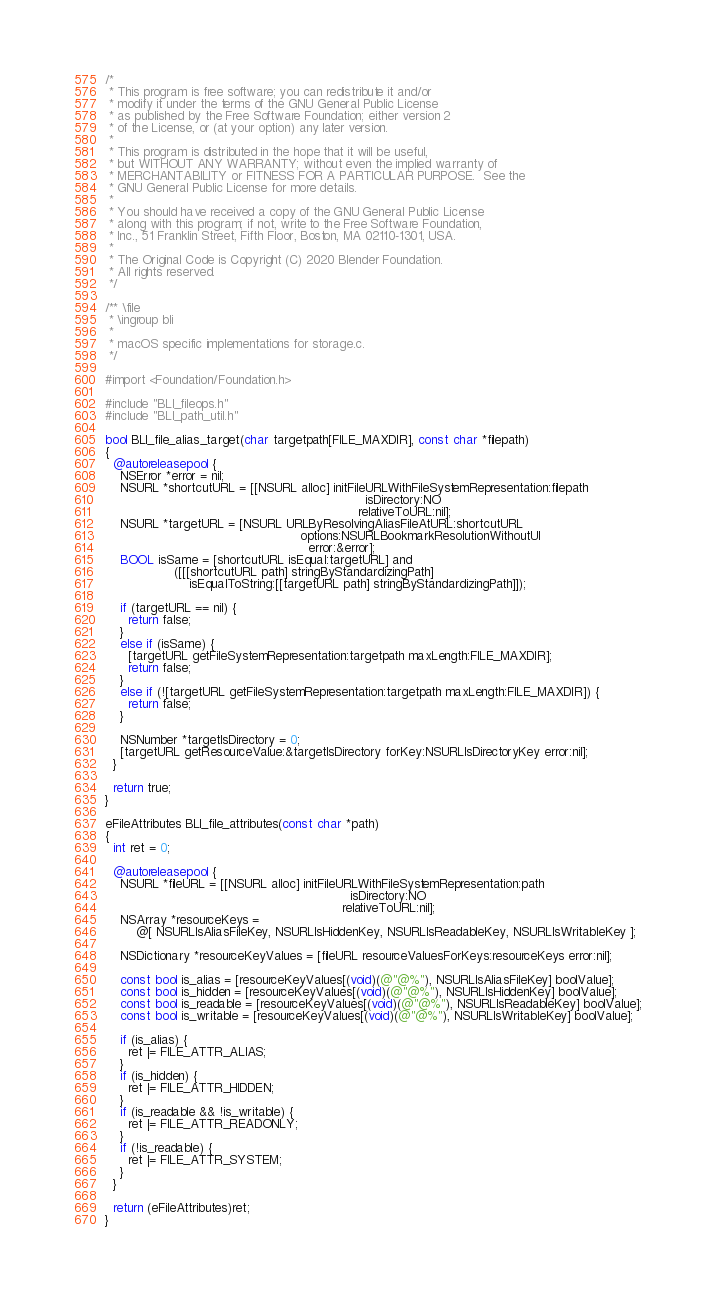Convert code to text. <code><loc_0><loc_0><loc_500><loc_500><_ObjectiveC_>/*
 * This program is free software; you can redistribute it and/or
 * modify it under the terms of the GNU General Public License
 * as published by the Free Software Foundation; either version 2
 * of the License, or (at your option) any later version.
 *
 * This program is distributed in the hope that it will be useful,
 * but WITHOUT ANY WARRANTY; without even the implied warranty of
 * MERCHANTABILITY or FITNESS FOR A PARTICULAR PURPOSE.  See the
 * GNU General Public License for more details.
 *
 * You should have received a copy of the GNU General Public License
 * along with this program; if not, write to the Free Software Foundation,
 * Inc., 51 Franklin Street, Fifth Floor, Boston, MA 02110-1301, USA.
 *
 * The Original Code is Copyright (C) 2020 Blender Foundation.
 * All rights reserved.
 */

/** \file
 * \ingroup bli
 *
 * macOS specific implementations for storage.c.
 */

#import <Foundation/Foundation.h>

#include "BLI_fileops.h"
#include "BLI_path_util.h"

bool BLI_file_alias_target(char targetpath[FILE_MAXDIR], const char *filepath)
{
  @autoreleasepool {
    NSError *error = nil;
    NSURL *shortcutURL = [[NSURL alloc] initFileURLWithFileSystemRepresentation:filepath
                                                                    isDirectory:NO
                                                                  relativeToURL:nil];
    NSURL *targetURL = [NSURL URLByResolvingAliasFileAtURL:shortcutURL
                                                   options:NSURLBookmarkResolutionWithoutUI
                                                     error:&error];
    BOOL isSame = [shortcutURL isEqual:targetURL] and
                  ([[[shortcutURL path] stringByStandardizingPath]
                      isEqualToString:[[targetURL path] stringByStandardizingPath]]);

    if (targetURL == nil) {
      return false;
    }
    else if (isSame) {
      [targetURL getFileSystemRepresentation:targetpath maxLength:FILE_MAXDIR];
      return false;
    }
    else if (![targetURL getFileSystemRepresentation:targetpath maxLength:FILE_MAXDIR]) {
      return false;
    }

    NSNumber *targetIsDirectory = 0;
    [targetURL getResourceValue:&targetIsDirectory forKey:NSURLIsDirectoryKey error:nil];
  }

  return true;
}

eFileAttributes BLI_file_attributes(const char *path)
{
  int ret = 0;

  @autoreleasepool {
    NSURL *fileURL = [[NSURL alloc] initFileURLWithFileSystemRepresentation:path
                                                                isDirectory:NO
                                                              relativeToURL:nil];
    NSArray *resourceKeys =
        @[ NSURLIsAliasFileKey, NSURLIsHiddenKey, NSURLIsReadableKey, NSURLIsWritableKey ];

    NSDictionary *resourceKeyValues = [fileURL resourceValuesForKeys:resourceKeys error:nil];

    const bool is_alias = [resourceKeyValues[(void)(@"@%"), NSURLIsAliasFileKey] boolValue];
    const bool is_hidden = [resourceKeyValues[(void)(@"@%"), NSURLIsHiddenKey] boolValue];
    const bool is_readable = [resourceKeyValues[(void)(@"@%"), NSURLIsReadableKey] boolValue];
    const bool is_writable = [resourceKeyValues[(void)(@"@%"), NSURLIsWritableKey] boolValue];

    if (is_alias) {
      ret |= FILE_ATTR_ALIAS;
    }
    if (is_hidden) {
      ret |= FILE_ATTR_HIDDEN;
    }
    if (is_readable && !is_writable) {
      ret |= FILE_ATTR_READONLY;
    }
    if (!is_readable) {
      ret |= FILE_ATTR_SYSTEM;
    }
  }

  return (eFileAttributes)ret;
}
</code> 